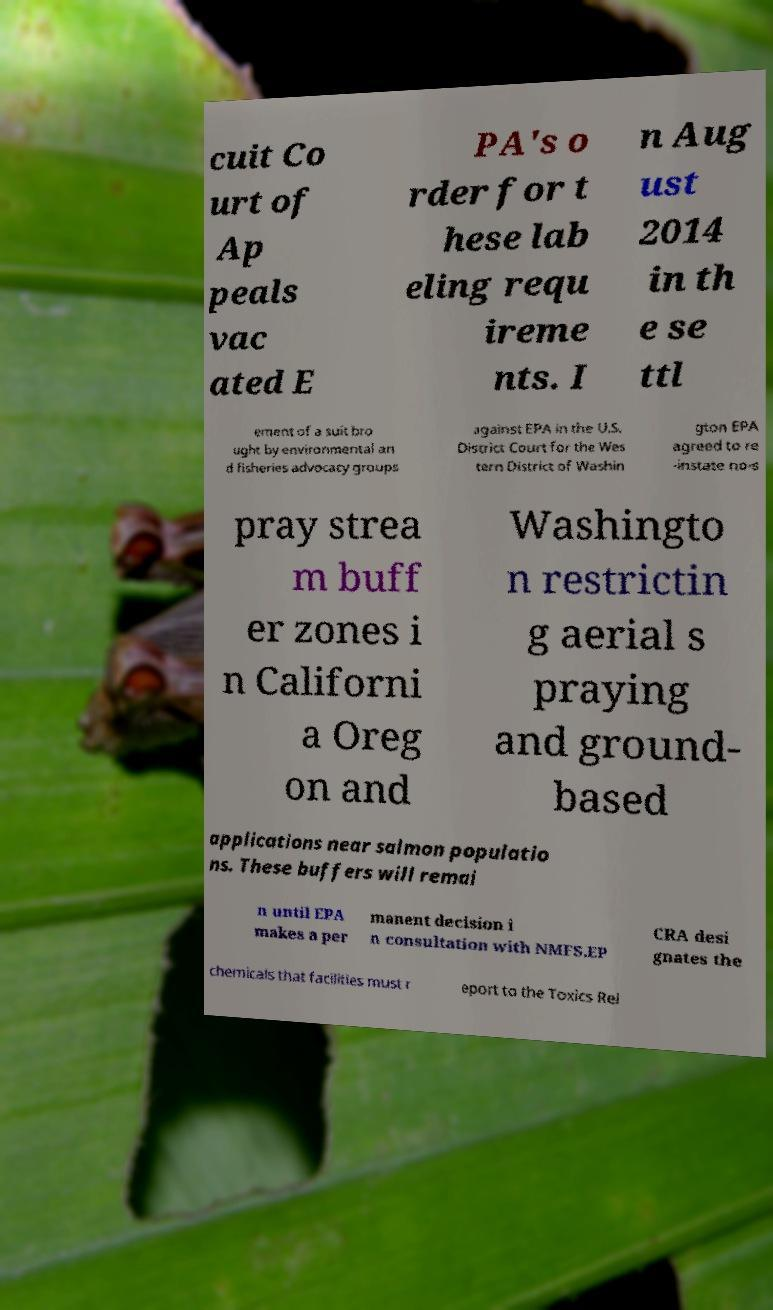Please identify and transcribe the text found in this image. cuit Co urt of Ap peals vac ated E PA's o rder for t hese lab eling requ ireme nts. I n Aug ust 2014 in th e se ttl ement of a suit bro ught by environmental an d fisheries advocacy groups against EPA in the U.S. District Court for the Wes tern District of Washin gton EPA agreed to re -instate no-s pray strea m buff er zones i n Californi a Oreg on and Washingto n restrictin g aerial s praying and ground- based applications near salmon populatio ns. These buffers will remai n until EPA makes a per manent decision i n consultation with NMFS.EP CRA desi gnates the chemicals that facilities must r eport to the Toxics Rel 